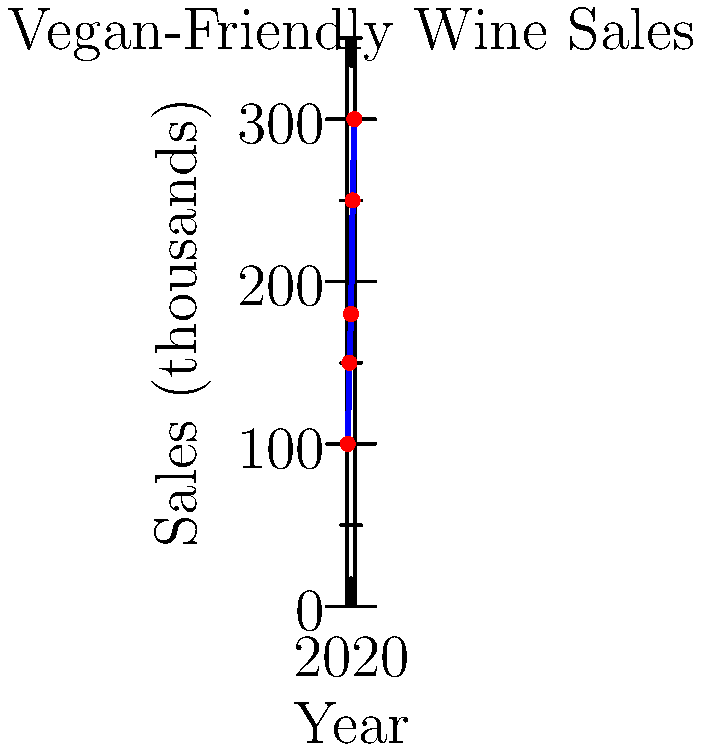As a publishing agent, you're analyzing the sales data of vegan-friendly wines over the past five years to support your book proposal. The graph shows the annual sales figures from 2018 to 2022. What was the approximate percentage increase in sales from 2018 to 2022? To calculate the percentage increase in sales from 2018 to 2022, we need to follow these steps:

1. Identify the sales figures for 2018 and 2022:
   2018 sales: 100 thousand
   2022 sales: 300 thousand

2. Calculate the difference in sales:
   $300 - 100 = 200$ thousand

3. Calculate the percentage increase:
   Percentage increase = $\frac{\text{Increase}}{\text{Original Value}} \times 100\%$
   
   $\frac{200}{100} \times 100\% = 2 \times 100\% = 200\%$

Therefore, the percentage increase in sales from 2018 to 2022 was approximately 200%.
Answer: 200% 